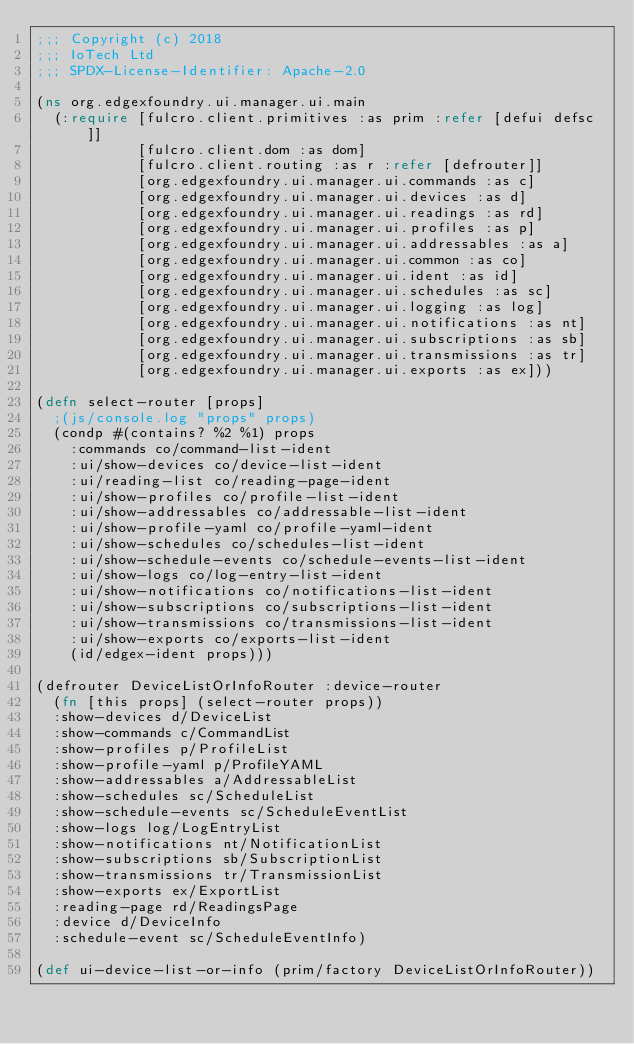<code> <loc_0><loc_0><loc_500><loc_500><_Clojure_>;;; Copyright (c) 2018
;;; IoTech Ltd
;;; SPDX-License-Identifier: Apache-2.0

(ns org.edgexfoundry.ui.manager.ui.main
  (:require [fulcro.client.primitives :as prim :refer [defui defsc]]
            [fulcro.client.dom :as dom]
            [fulcro.client.routing :as r :refer [defrouter]]
            [org.edgexfoundry.ui.manager.ui.commands :as c]
            [org.edgexfoundry.ui.manager.ui.devices :as d]
            [org.edgexfoundry.ui.manager.ui.readings :as rd]
            [org.edgexfoundry.ui.manager.ui.profiles :as p]
            [org.edgexfoundry.ui.manager.ui.addressables :as a]
            [org.edgexfoundry.ui.manager.ui.common :as co]
            [org.edgexfoundry.ui.manager.ui.ident :as id]
            [org.edgexfoundry.ui.manager.ui.schedules :as sc]
            [org.edgexfoundry.ui.manager.ui.logging :as log]
            [org.edgexfoundry.ui.manager.ui.notifications :as nt]
            [org.edgexfoundry.ui.manager.ui.subscriptions :as sb]
            [org.edgexfoundry.ui.manager.ui.transmissions :as tr]
            [org.edgexfoundry.ui.manager.ui.exports :as ex]))

(defn select-router [props]
  ;(js/console.log "props" props)
  (condp #(contains? %2 %1) props
    :commands co/command-list-ident
    :ui/show-devices co/device-list-ident
    :ui/reading-list co/reading-page-ident
    :ui/show-profiles co/profile-list-ident
    :ui/show-addressables co/addressable-list-ident
    :ui/show-profile-yaml co/profile-yaml-ident
    :ui/show-schedules co/schedules-list-ident
    :ui/show-schedule-events co/schedule-events-list-ident
    :ui/show-logs co/log-entry-list-ident
    :ui/show-notifications co/notifications-list-ident
    :ui/show-subscriptions co/subscriptions-list-ident
    :ui/show-transmissions co/transmissions-list-ident
    :ui/show-exports co/exports-list-ident
    (id/edgex-ident props)))

(defrouter DeviceListOrInfoRouter :device-router
  (fn [this props] (select-router props))
  :show-devices d/DeviceList
  :show-commands c/CommandList
  :show-profiles p/ProfileList
  :show-profile-yaml p/ProfileYAML
  :show-addressables a/AddressableList
  :show-schedules sc/ScheduleList
  :show-schedule-events sc/ScheduleEventList
  :show-logs log/LogEntryList
  :show-notifications nt/NotificationList
  :show-subscriptions sb/SubscriptionList
  :show-transmissions tr/TransmissionList
  :show-exports ex/ExportList
  :reading-page rd/ReadingsPage
  :device d/DeviceInfo
  :schedule-event sc/ScheduleEventInfo)

(def ui-device-list-or-info (prim/factory DeviceListOrInfoRouter))
</code> 